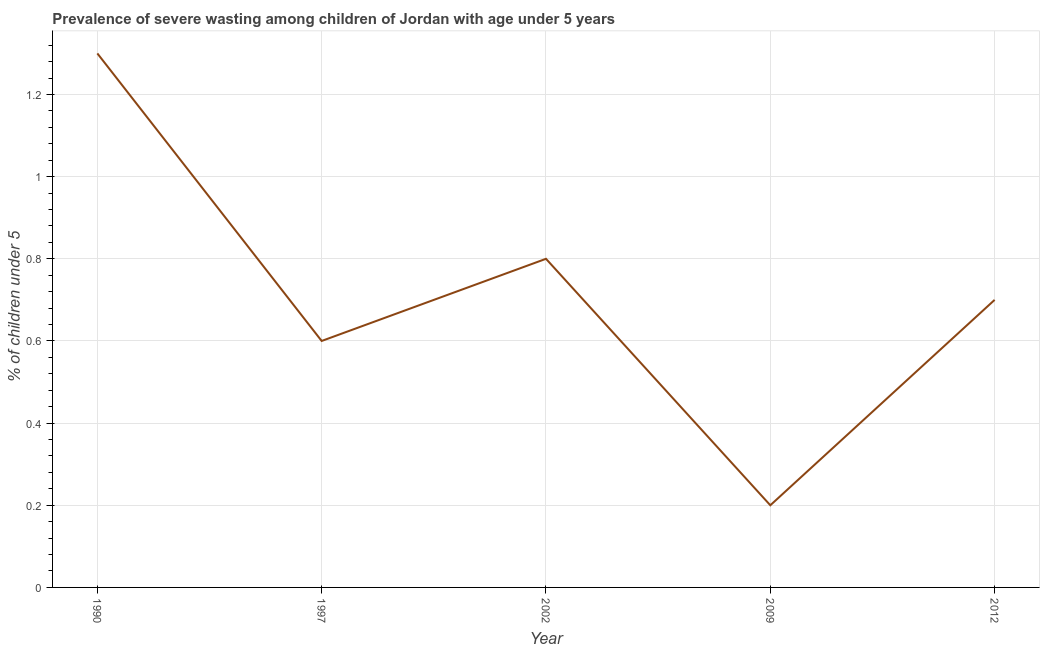What is the prevalence of severe wasting in 1990?
Offer a very short reply. 1.3. Across all years, what is the maximum prevalence of severe wasting?
Your response must be concise. 1.3. Across all years, what is the minimum prevalence of severe wasting?
Provide a short and direct response. 0.2. In which year was the prevalence of severe wasting minimum?
Give a very brief answer. 2009. What is the sum of the prevalence of severe wasting?
Keep it short and to the point. 3.6. What is the difference between the prevalence of severe wasting in 1990 and 2002?
Make the answer very short. 0.5. What is the average prevalence of severe wasting per year?
Your answer should be very brief. 0.72. What is the median prevalence of severe wasting?
Your answer should be very brief. 0.7. In how many years, is the prevalence of severe wasting greater than 1.08 %?
Your answer should be very brief. 1. What is the ratio of the prevalence of severe wasting in 1990 to that in 2012?
Ensure brevity in your answer.  1.86. What is the difference between the highest and the second highest prevalence of severe wasting?
Offer a very short reply. 0.5. What is the difference between the highest and the lowest prevalence of severe wasting?
Offer a very short reply. 1.1. Does the graph contain any zero values?
Provide a succinct answer. No. What is the title of the graph?
Keep it short and to the point. Prevalence of severe wasting among children of Jordan with age under 5 years. What is the label or title of the X-axis?
Provide a succinct answer. Year. What is the label or title of the Y-axis?
Keep it short and to the point.  % of children under 5. What is the  % of children under 5 of 1990?
Your answer should be very brief. 1.3. What is the  % of children under 5 in 1997?
Your answer should be compact. 0.6. What is the  % of children under 5 in 2002?
Offer a very short reply. 0.8. What is the  % of children under 5 of 2009?
Make the answer very short. 0.2. What is the  % of children under 5 of 2012?
Give a very brief answer. 0.7. What is the difference between the  % of children under 5 in 1990 and 2002?
Your response must be concise. 0.5. What is the difference between the  % of children under 5 in 1990 and 2012?
Provide a succinct answer. 0.6. What is the difference between the  % of children under 5 in 1997 and 2009?
Your answer should be very brief. 0.4. What is the difference between the  % of children under 5 in 1997 and 2012?
Provide a succinct answer. -0.1. What is the difference between the  % of children under 5 in 2002 and 2009?
Provide a short and direct response. 0.6. What is the ratio of the  % of children under 5 in 1990 to that in 1997?
Give a very brief answer. 2.17. What is the ratio of the  % of children under 5 in 1990 to that in 2002?
Keep it short and to the point. 1.62. What is the ratio of the  % of children under 5 in 1990 to that in 2012?
Your answer should be very brief. 1.86. What is the ratio of the  % of children under 5 in 1997 to that in 2002?
Your answer should be very brief. 0.75. What is the ratio of the  % of children under 5 in 1997 to that in 2009?
Your response must be concise. 3. What is the ratio of the  % of children under 5 in 1997 to that in 2012?
Your answer should be very brief. 0.86. What is the ratio of the  % of children under 5 in 2002 to that in 2009?
Offer a terse response. 4. What is the ratio of the  % of children under 5 in 2002 to that in 2012?
Give a very brief answer. 1.14. What is the ratio of the  % of children under 5 in 2009 to that in 2012?
Your answer should be compact. 0.29. 